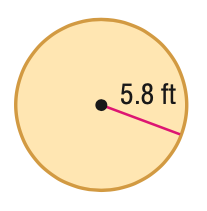Answer the mathemtical geometry problem and directly provide the correct option letter.
Question: Find the area of the figure. Round to the nearest tenth.
Choices: A: 36.4 B: 105.7 C: 211.4 D: 422.7 B 